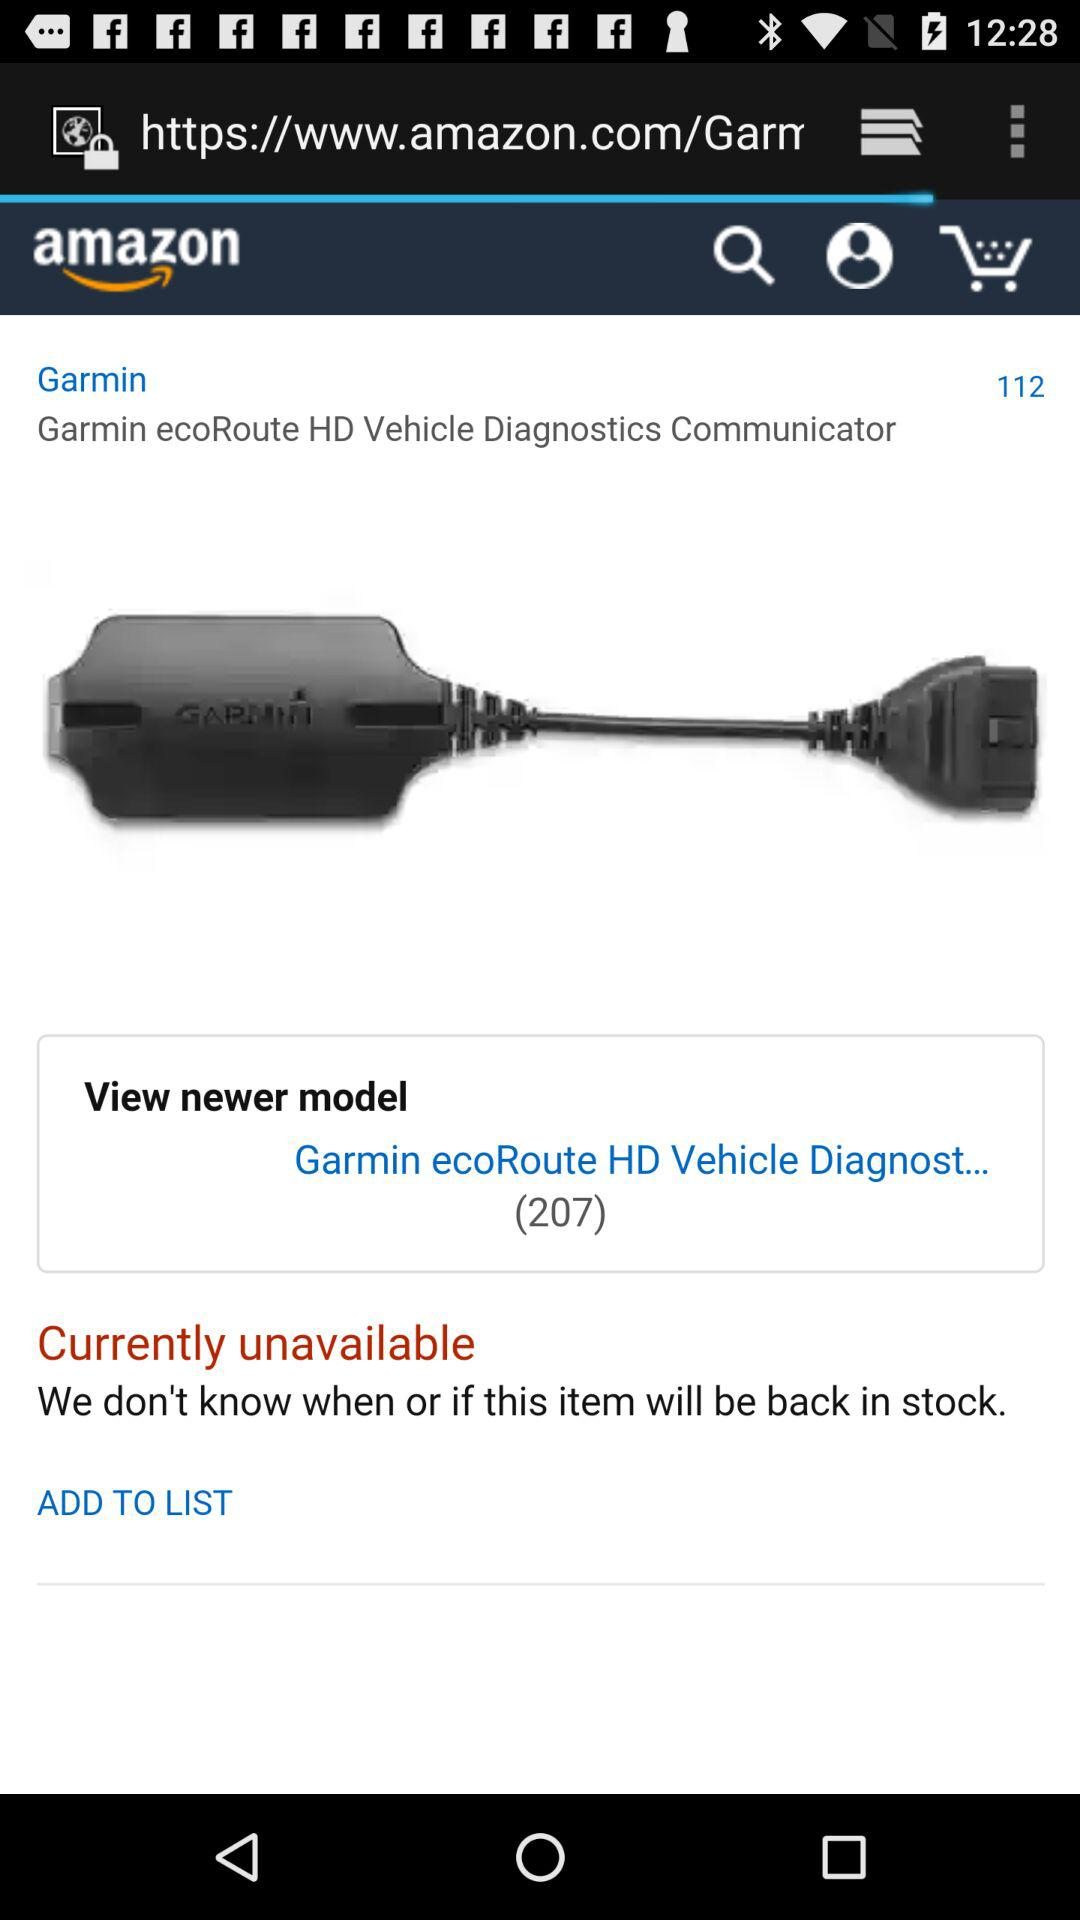What is the name of the new model of communicator? The name of the new model of communicator is "Garmin ecoRoute HD Vehicle Diagnost...". 